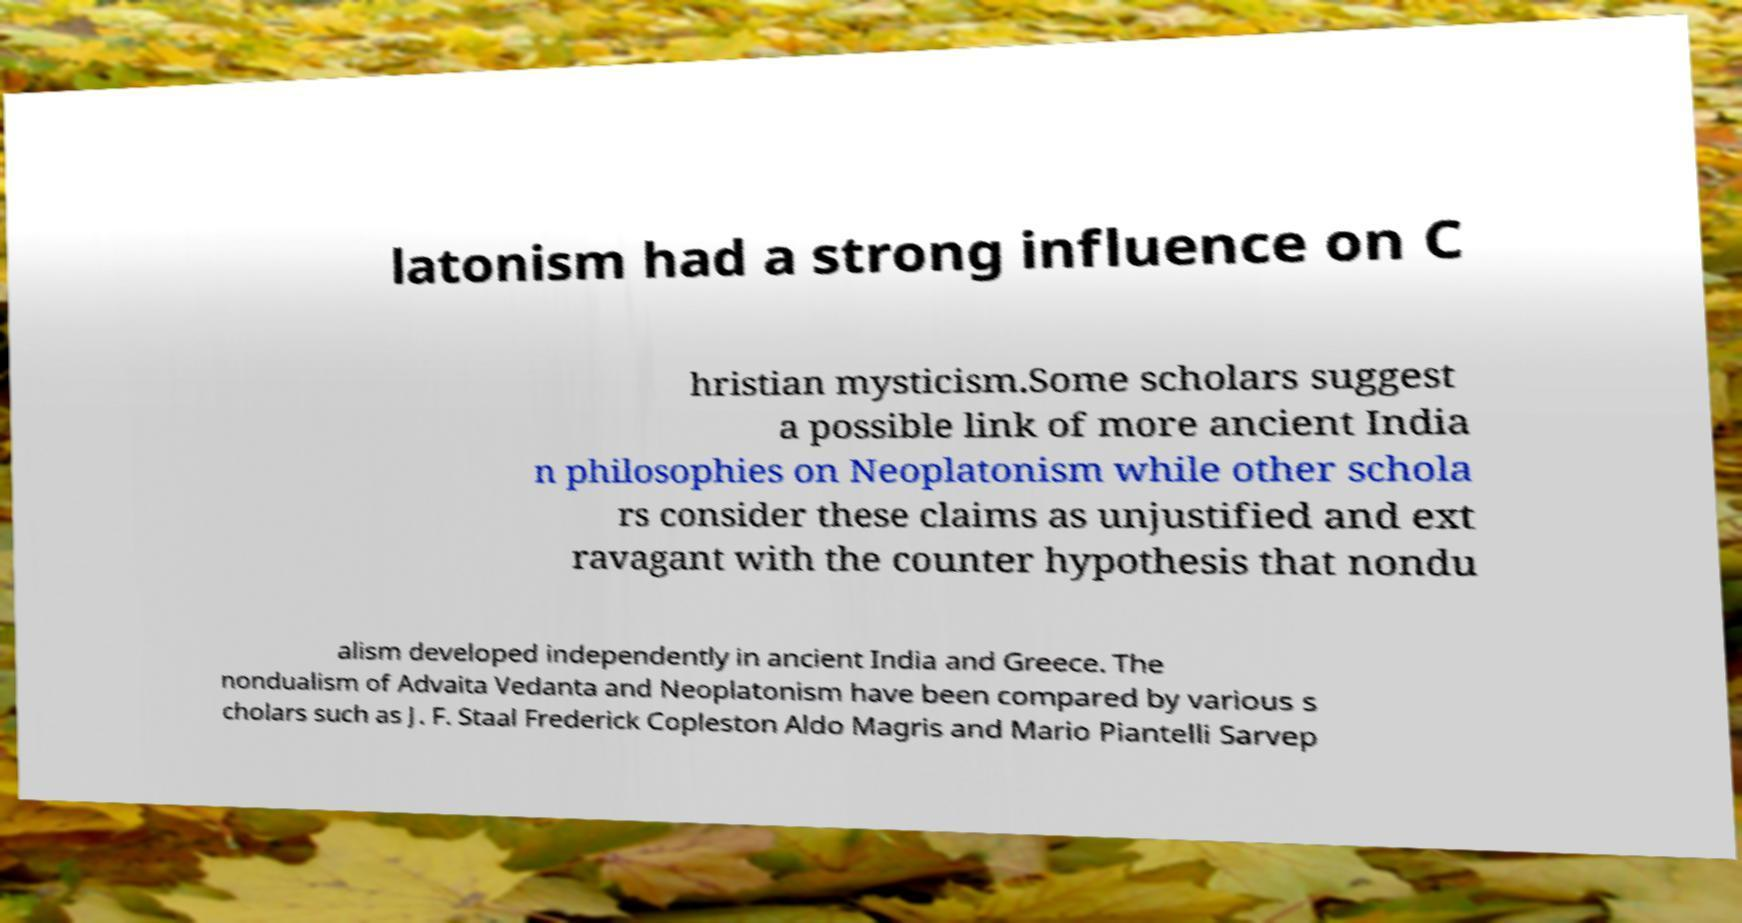There's text embedded in this image that I need extracted. Can you transcribe it verbatim? latonism had a strong influence on C hristian mysticism.Some scholars suggest a possible link of more ancient India n philosophies on Neoplatonism while other schola rs consider these claims as unjustified and ext ravagant with the counter hypothesis that nondu alism developed independently in ancient India and Greece. The nondualism of Advaita Vedanta and Neoplatonism have been compared by various s cholars such as J. F. Staal Frederick Copleston Aldo Magris and Mario Piantelli Sarvep 